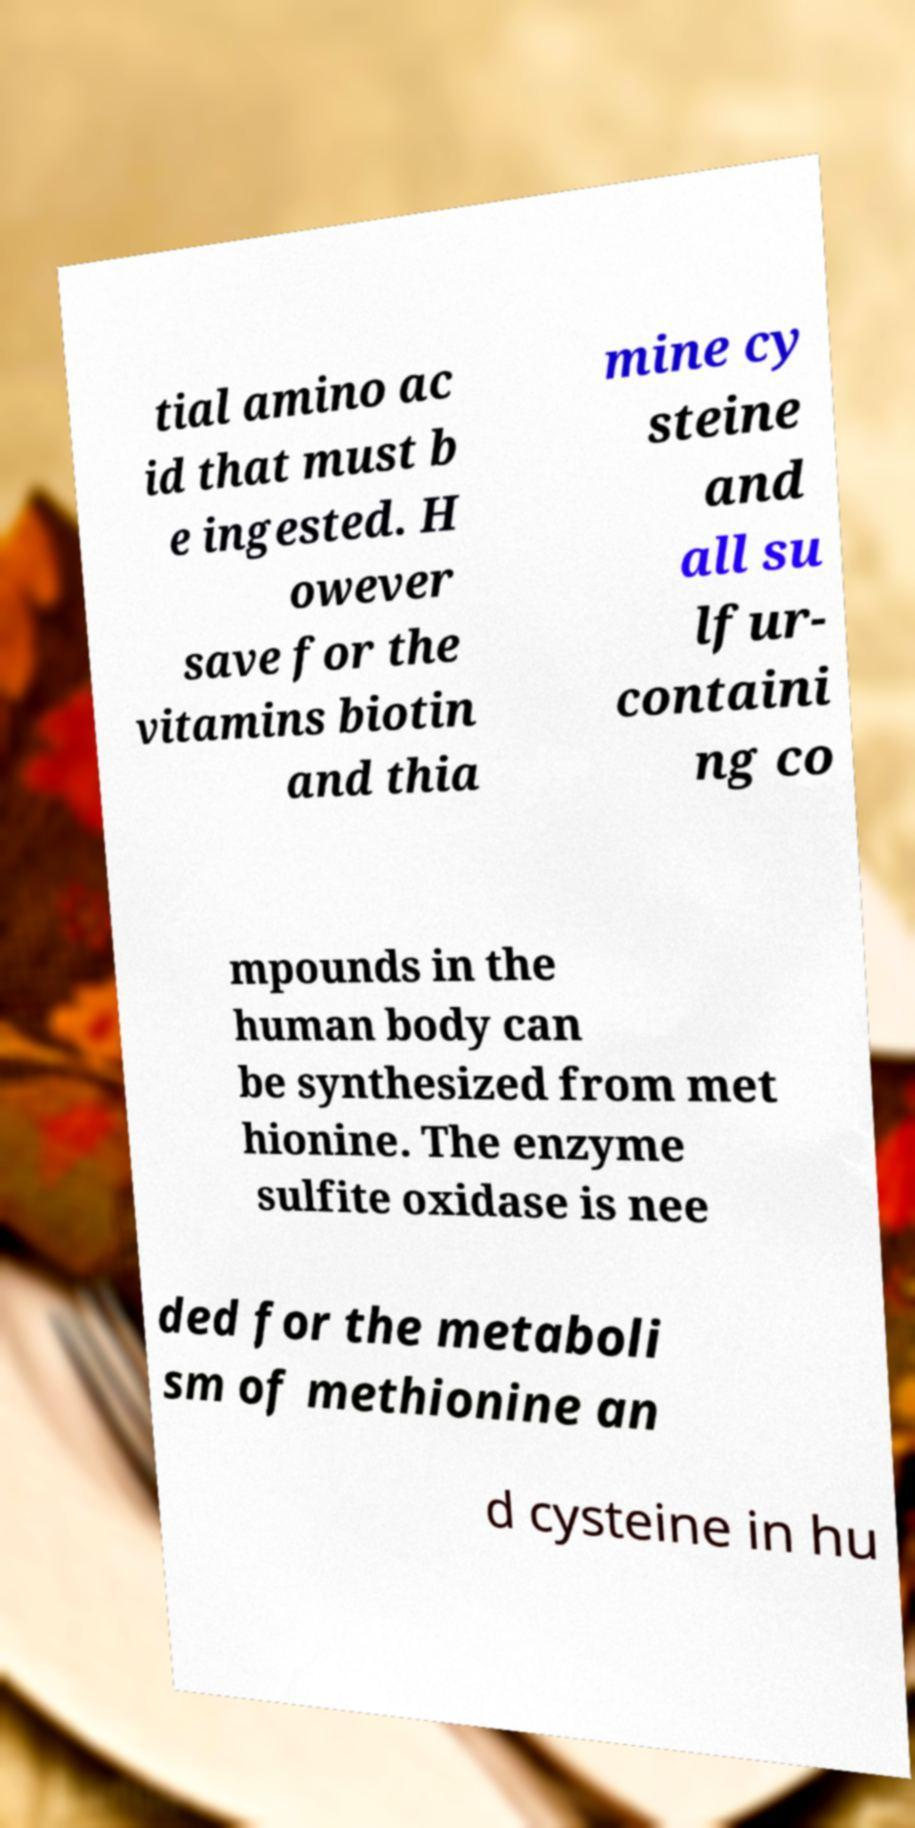Please read and relay the text visible in this image. What does it say? tial amino ac id that must b e ingested. H owever save for the vitamins biotin and thia mine cy steine and all su lfur- containi ng co mpounds in the human body can be synthesized from met hionine. The enzyme sulfite oxidase is nee ded for the metaboli sm of methionine an d cysteine in hu 